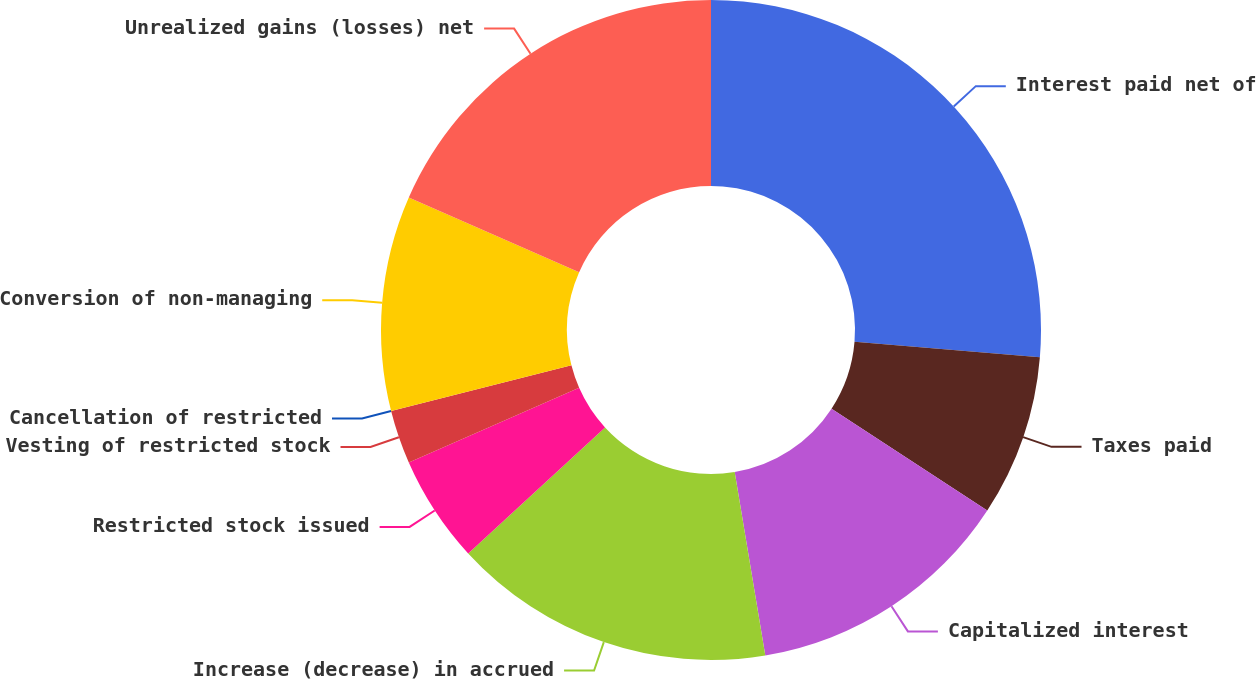Convert chart to OTSL. <chart><loc_0><loc_0><loc_500><loc_500><pie_chart><fcel>Interest paid net of<fcel>Taxes paid<fcel>Capitalized interest<fcel>Increase (decrease) in accrued<fcel>Restricted stock issued<fcel>Vesting of restricted stock<fcel>Cancellation of restricted<fcel>Conversion of non-managing<fcel>Unrealized gains (losses) net<nl><fcel>26.31%<fcel>7.9%<fcel>13.16%<fcel>15.79%<fcel>5.26%<fcel>2.63%<fcel>0.0%<fcel>10.53%<fcel>18.42%<nl></chart> 